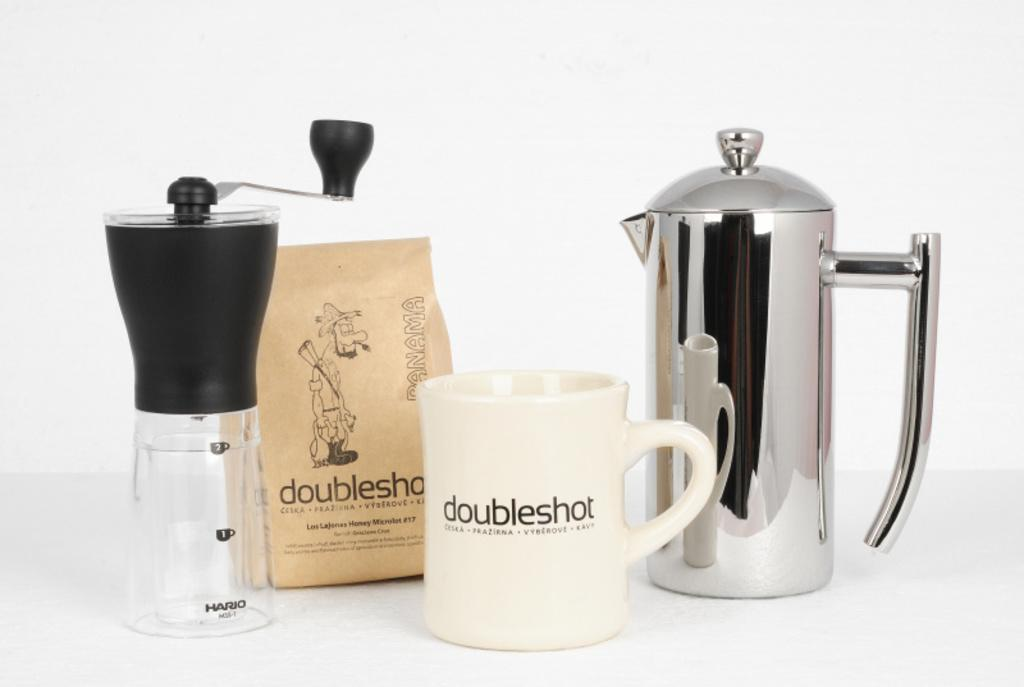<image>
Give a short and clear explanation of the subsequent image. a white mug in front of other containers that says 'doubleshot' on it 